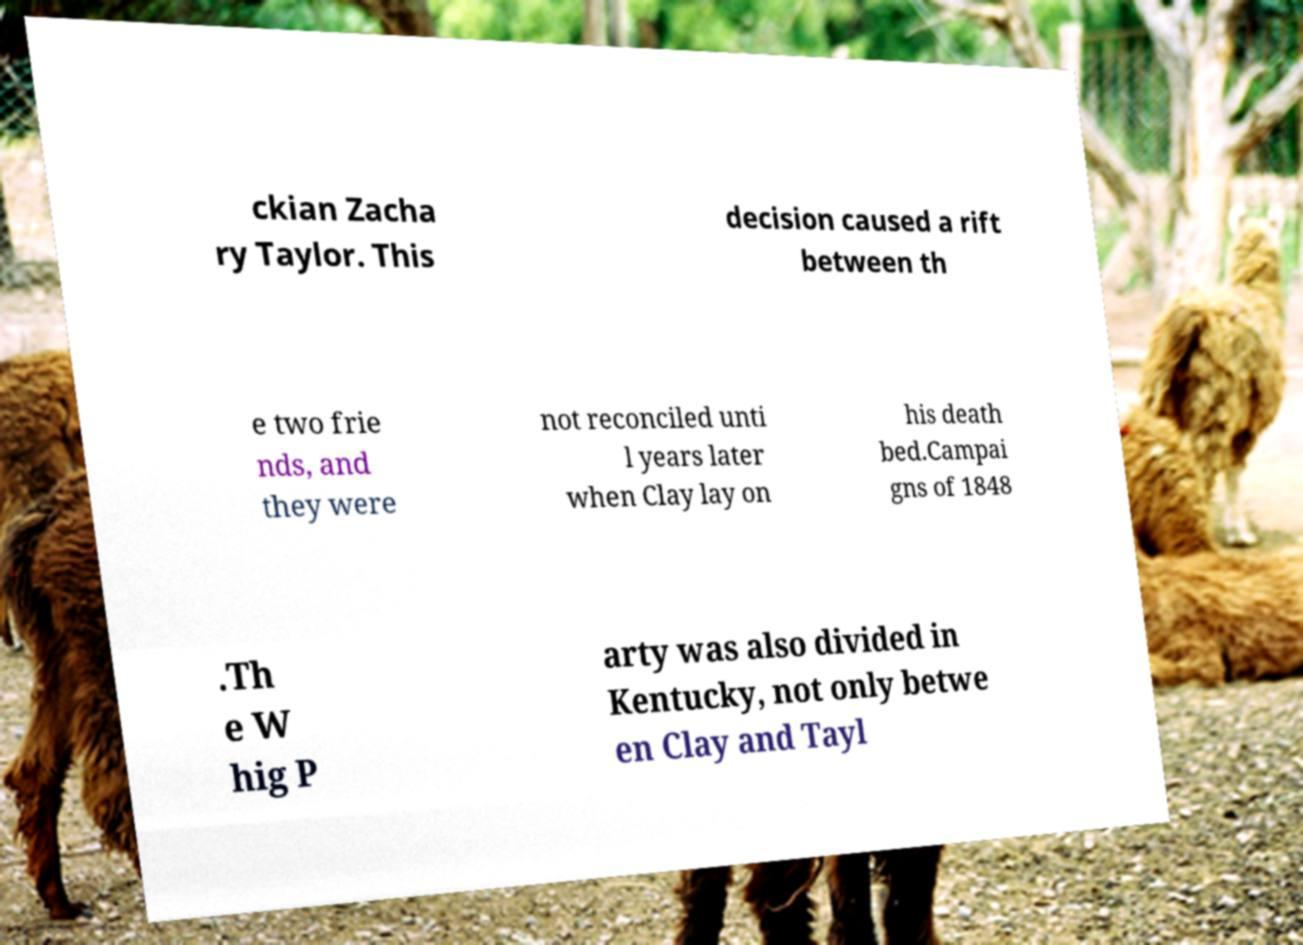Please identify and transcribe the text found in this image. ckian Zacha ry Taylor. This decision caused a rift between th e two frie nds, and they were not reconciled unti l years later when Clay lay on his death bed.Campai gns of 1848 .Th e W hig P arty was also divided in Kentucky, not only betwe en Clay and Tayl 